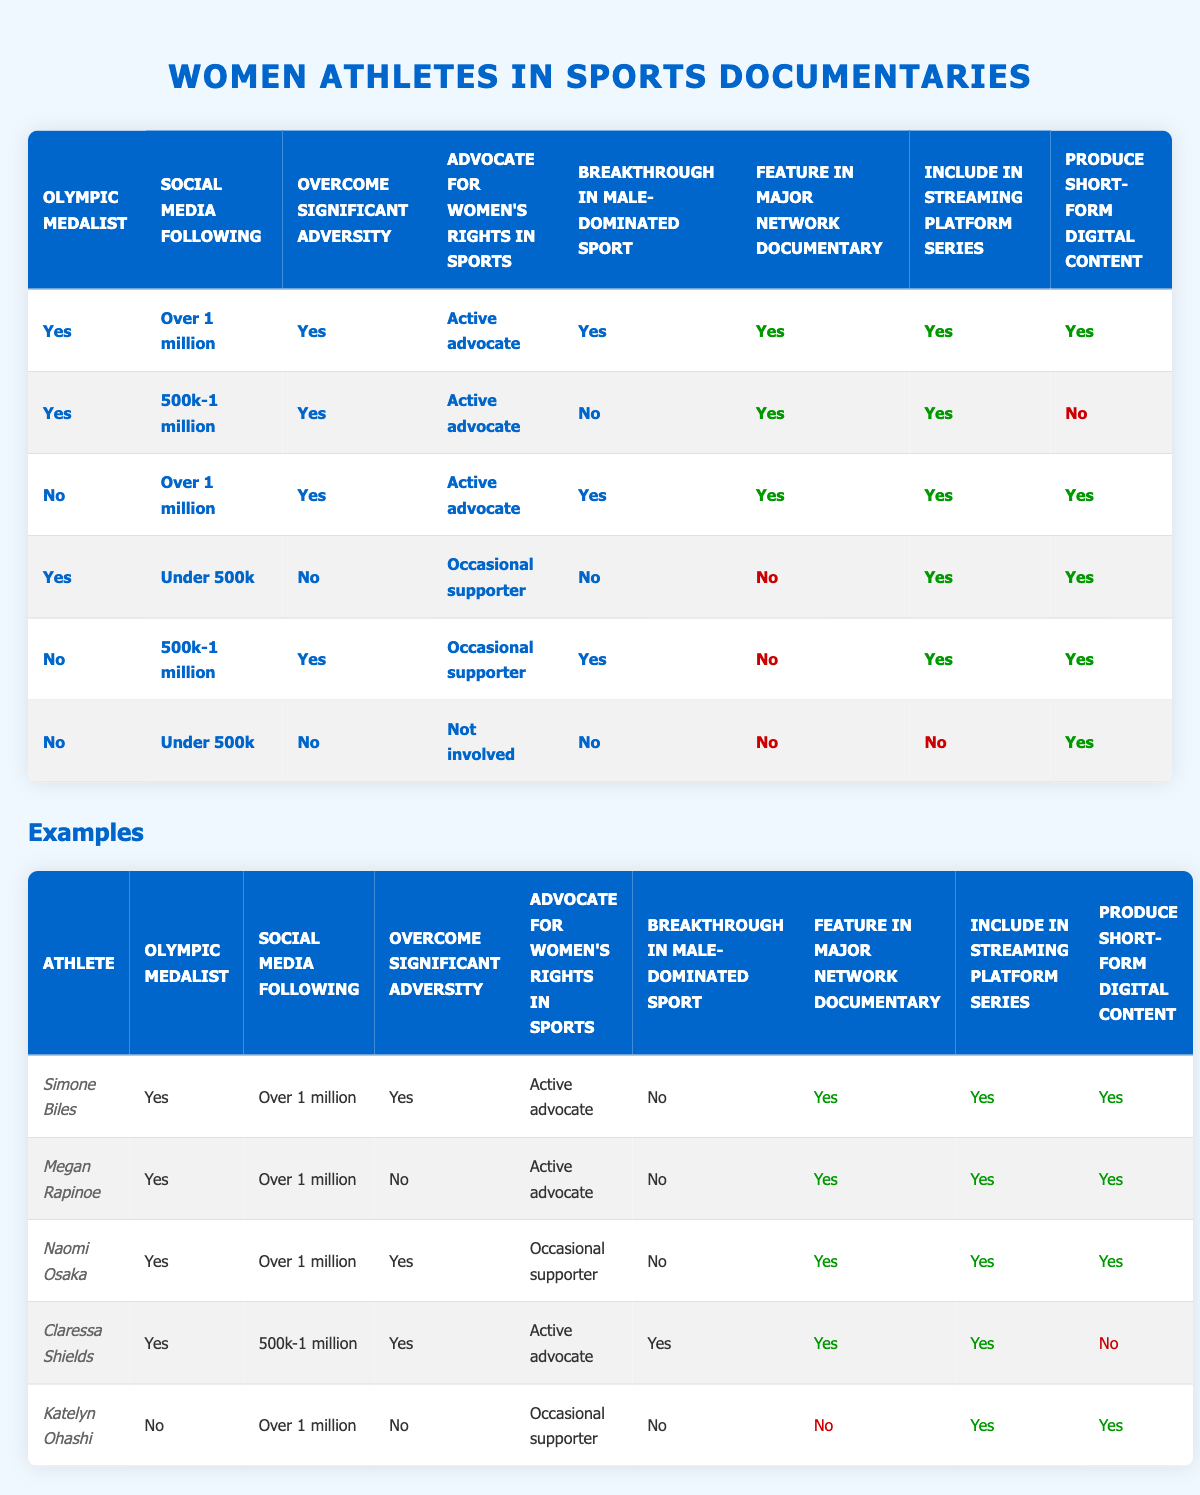What percentage of athletes who are Olympic medalists and have over 1 million social media followers are featured in a major network documentary? There are 3 athletes who are Olympic medalists and have over 1 million social media followers: Simone Biles, Megan Rapinoe, and Naomi Osaka. All of them are featured in a major network documentary, which makes the percentage 100%.
Answer: 100% How many athletes are included in streaming platform series but not featured in major network documentaries? From the table, Katelyn Ohashi and Claressa Shields are included in streaming platform series but are not featured in major network documentaries. Therefore, the total is 2.
Answer: 2 Is there any athlete who has overcome significant adversity but is not an advocate for women's rights in sports? Yes, Claressa Shields has overcome significant adversity but is listed as an active advocate for women's rights, while Katelyn Ohashi is noted as an occasional supporter, making the affirmation true.
Answer: Yes For athletes with a social media following under 500k, how many are featured in short-form digital content? Katelyn Ohashi is the only athlete with a social media following under 500k, who is featured in short-form digital content. Therefore, the answer is one.
Answer: 1 What is the condition combination of the athlete excluded from a major network documentary but included in streaming series and short-form content? Katelyn Ohashi was excluded from the major network documentary (Yes) but is included in both the streaming series (Yes) and short-form digital content (Yes). The combination is: No, Over 1 million, No, Occasional supporter, No.
Answer: No, Over 1 million, No, Occasional supporter, No How many athletes have not broken through in a male-dominated sport but have over 1 million social media followers? This includes athletes like Katelyn Ohashi and Megan Rapinoe who have over 1 million social media followers but have not broken through in male-dominated sports. Thus, the count is 2.
Answer: 2 Which athlete has the highest social media following and is not featured in short-form digital content? Claressa Shields has a social media following between 500k and 1 million and is not featured in short-form digital content. Hence, she is the athlete with the highest social media following, who meets that criterion.
Answer: Claressa Shields 